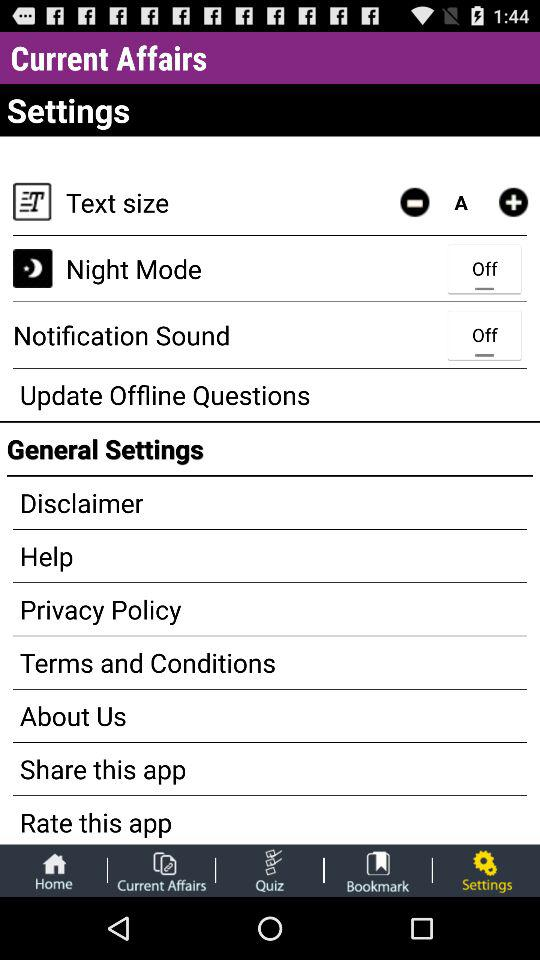How many notifications are there in "Settings"?
When the provided information is insufficient, respond with <no answer>. <no answer> 